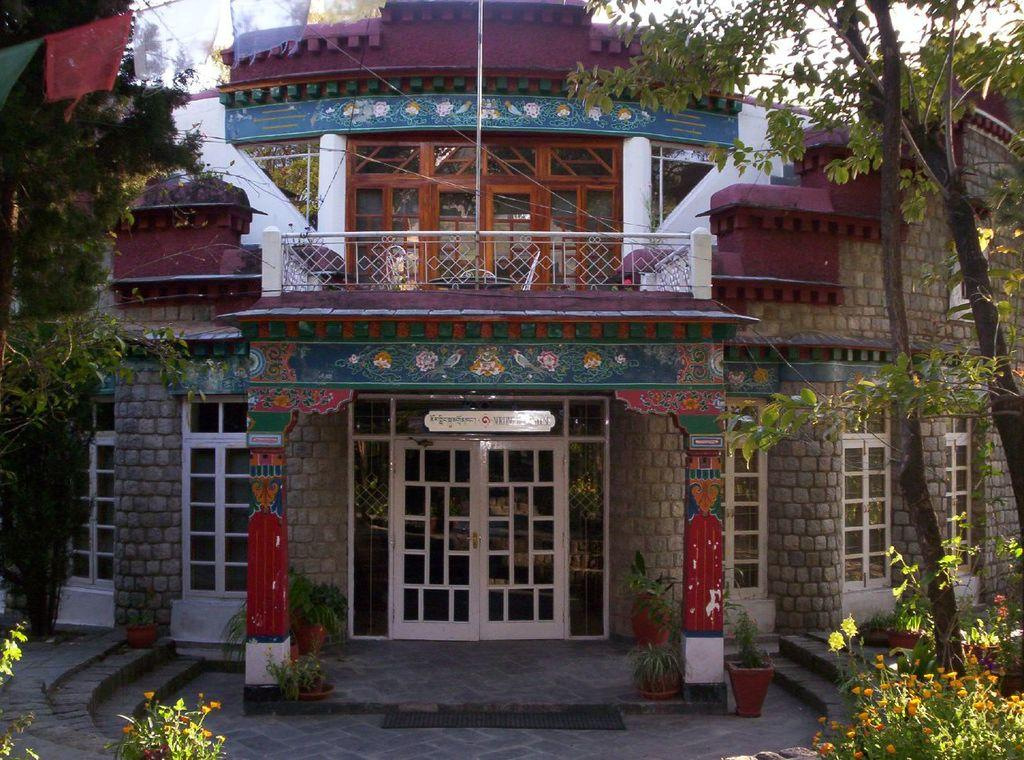What type of structure is visible in the image? There is a building in the image. What features can be seen on the building? The building has doors and windows. What signage is present in the image? There is a name board in the image. What type of vegetation is present inside the building? There are house plants in the image. What type of plants with flowers are present in the image? There are plants with flowers in the image. What can be seen in the background of the image? There are trees, flags, and the sky visible in the background of the image. What type of wood is used to make the hair visible in the image? There is no wood or hair present in the image. 